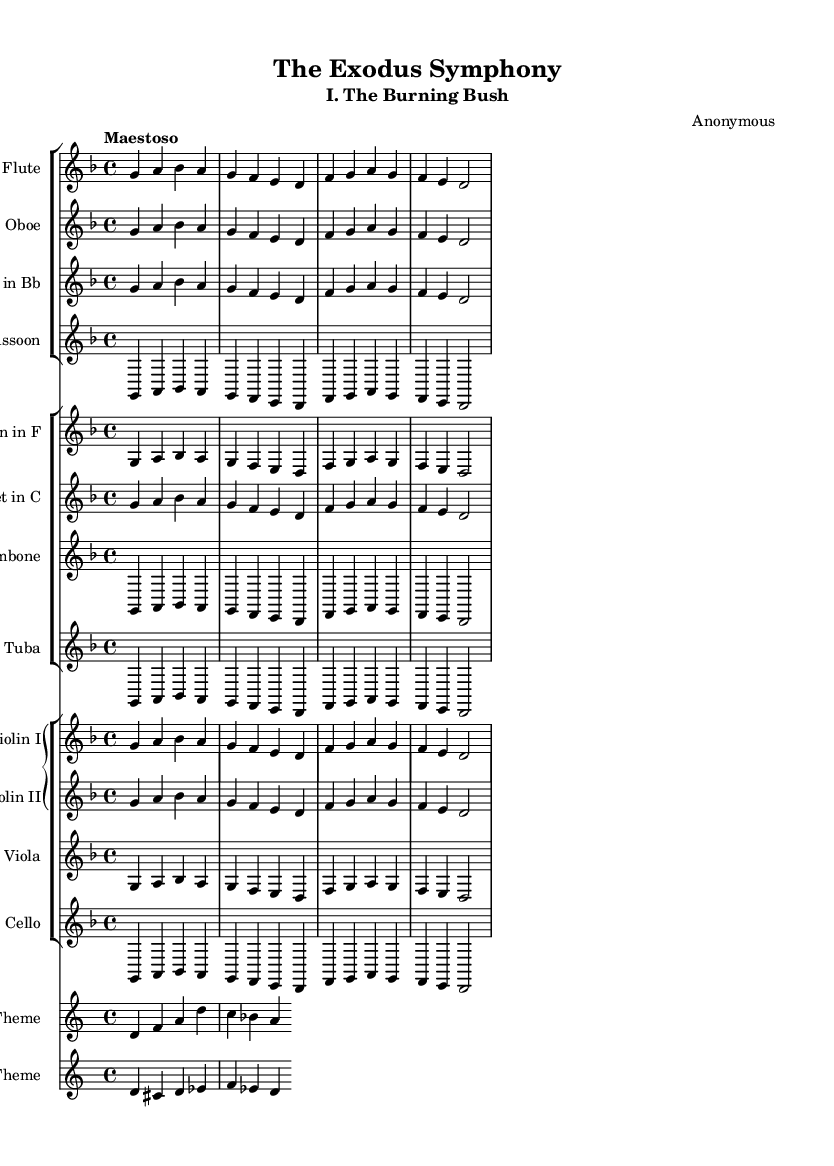What is the key signature of this music? The key signature is D minor, which is indicated with one flat (B flat) shown at the beginning of the staff.
Answer: D minor What is the time signature of this music? The time signature is 4/4, as it is indicated at the beginning of the sheet music, which means there are four beats per measure with a quarter note getting one beat.
Answer: 4/4 What is the tempo marking of the piece? The tempo marking is "Maestoso," which suggests a majestic and dignified pace for the performance, typically slower than moderato.
Answer: Maestoso How many different instrument groups are there in this symphony? The symphony contains four distinct groups of instruments: woodwinds, brass, strings, and the additional themes for Moses and Pharaoh are included within the grand staff.
Answer: Four What musical themes are present in this score? The score includes two specific themes: Moses' Theme and Pharaoh's Theme, indicated by their respective labels within the sheet music.
Answer: Moses' Theme and Pharaoh's Theme Which instruments are included in the woodwind section? The woodwind section consists of flute, oboe, clarinet, and bassoon, as indicated by their respective staves within the woodwind staff group.
Answer: Flute, Oboe, Clarinet, Bassoon What is the opening note of Moses' Theme? The opening note of Moses’ Theme is D, which is the first note written in the staff for this particular theme.
Answer: D 